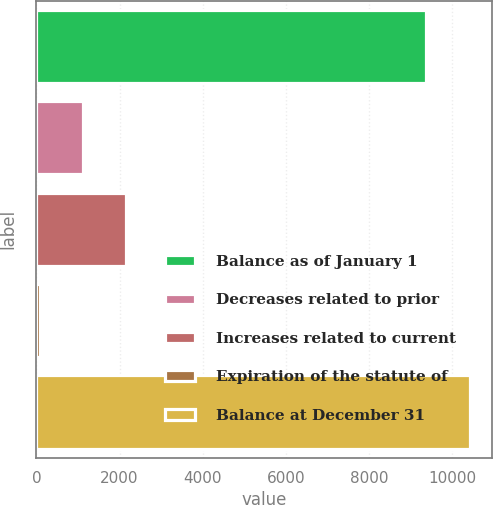Convert chart to OTSL. <chart><loc_0><loc_0><loc_500><loc_500><bar_chart><fcel>Balance as of January 1<fcel>Decreases related to prior<fcel>Increases related to current<fcel>Expiration of the statute of<fcel>Balance at December 31<nl><fcel>9358<fcel>1129<fcel>2162<fcel>96<fcel>10426<nl></chart> 